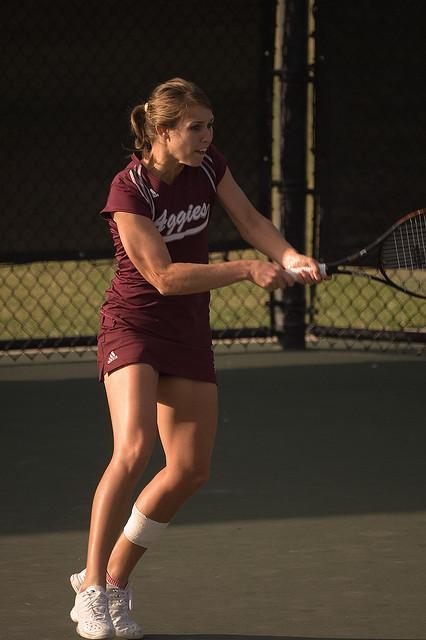How many giraffe heads can you see?
Give a very brief answer. 0. 